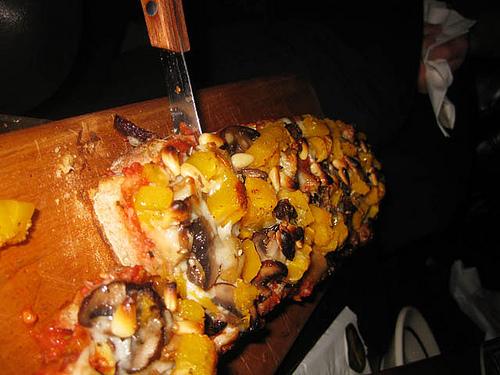What is the knife handle made of?
Concise answer only. Wood. What is the knife cutting?
Write a very short answer. Pizza. How many knives are there?
Concise answer only. 1. 